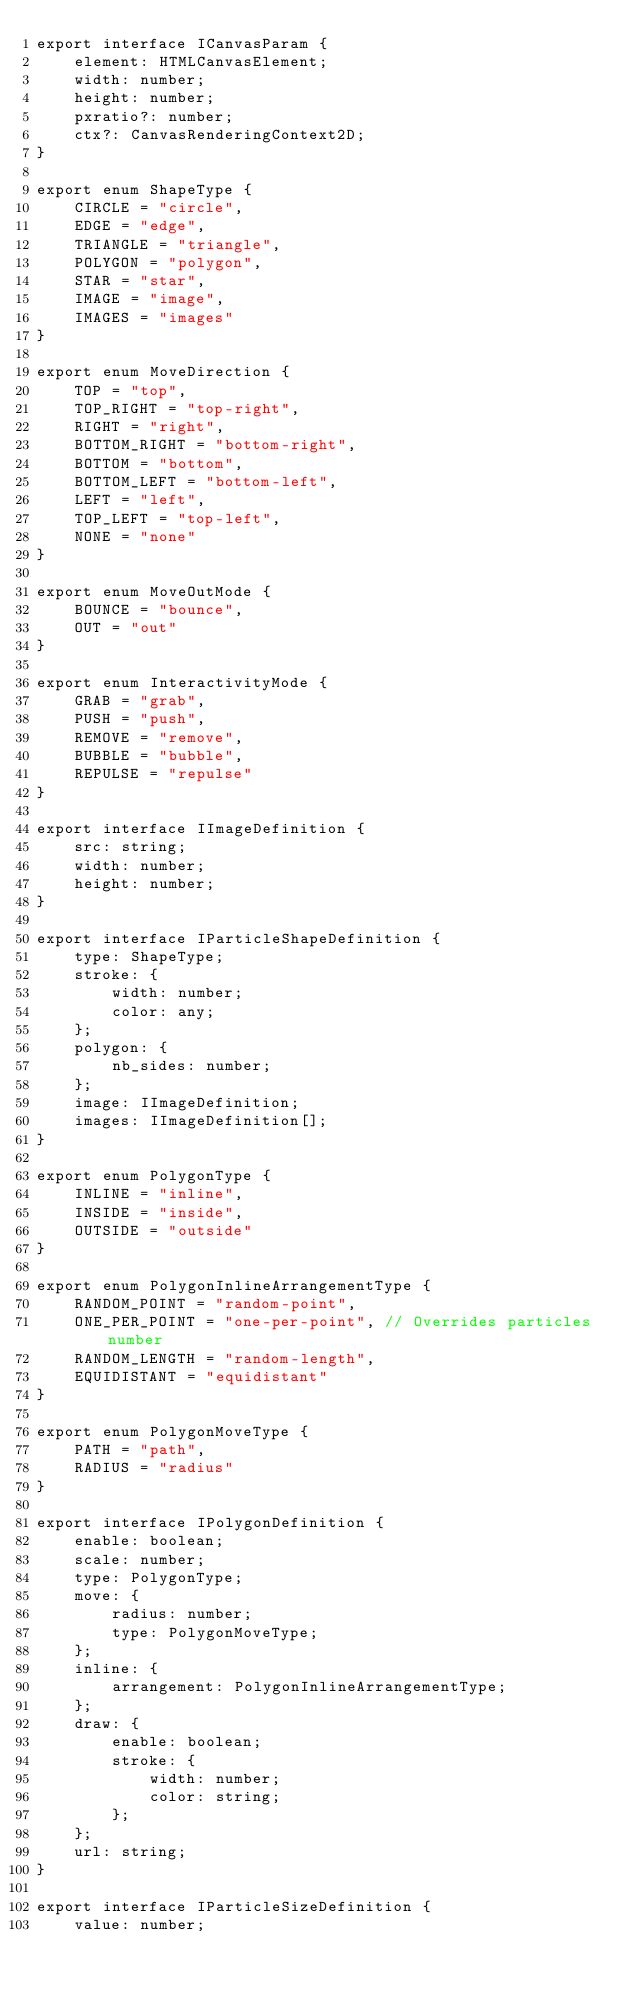<code> <loc_0><loc_0><loc_500><loc_500><_TypeScript_>export interface ICanvasParam {
	element: HTMLCanvasElement;
	width: number;
	height: number;
	pxratio?: number;
	ctx?: CanvasRenderingContext2D;
}

export enum ShapeType {
	CIRCLE = "circle",
	EDGE = "edge",
	TRIANGLE = "triangle",
	POLYGON = "polygon",
	STAR = "star",
	IMAGE = "image",
	IMAGES = "images"
}

export enum MoveDirection {
	TOP = "top",
	TOP_RIGHT = "top-right",
	RIGHT = "right",
	BOTTOM_RIGHT = "bottom-right",
	BOTTOM = "bottom",
	BOTTOM_LEFT = "bottom-left",
	LEFT = "left",
	TOP_LEFT = "top-left",
	NONE = "none"
}

export enum MoveOutMode {
	BOUNCE = "bounce",
	OUT = "out"
}

export enum InteractivityMode {
	GRAB = "grab",
	PUSH = "push",
	REMOVE = "remove",
	BUBBLE = "bubble",
	REPULSE = "repulse"
}

export interface IImageDefinition {
	src: string;
	width: number;
	height: number;
}

export interface IParticleShapeDefinition {
	type: ShapeType;
	stroke: {
		width: number;
		color: any;
	};
	polygon: {
		nb_sides: number;
	};
	image: IImageDefinition;
	images: IImageDefinition[];
}

export enum PolygonType {
	INLINE = "inline",
	INSIDE = "inside",
	OUTSIDE = "outside"
}

export enum PolygonInlineArrangementType {
	RANDOM_POINT = "random-point",
	ONE_PER_POINT = "one-per-point", // Overrides particles number
	RANDOM_LENGTH = "random-length",
	EQUIDISTANT = "equidistant"
}

export enum PolygonMoveType {
	PATH = "path",
	RADIUS = "radius"
}

export interface IPolygonDefinition {
	enable: boolean;
	scale: number;
	type: PolygonType;
	move: {
		radius: number;
		type: PolygonMoveType;
	};
	inline: {
		arrangement: PolygonInlineArrangementType;
	};
	draw: {
		enable: boolean;
		stroke: {
			width: number;
			color: string;
		};
	};
	url: string;
}

export interface IParticleSizeDefinition {
	value: number;</code> 